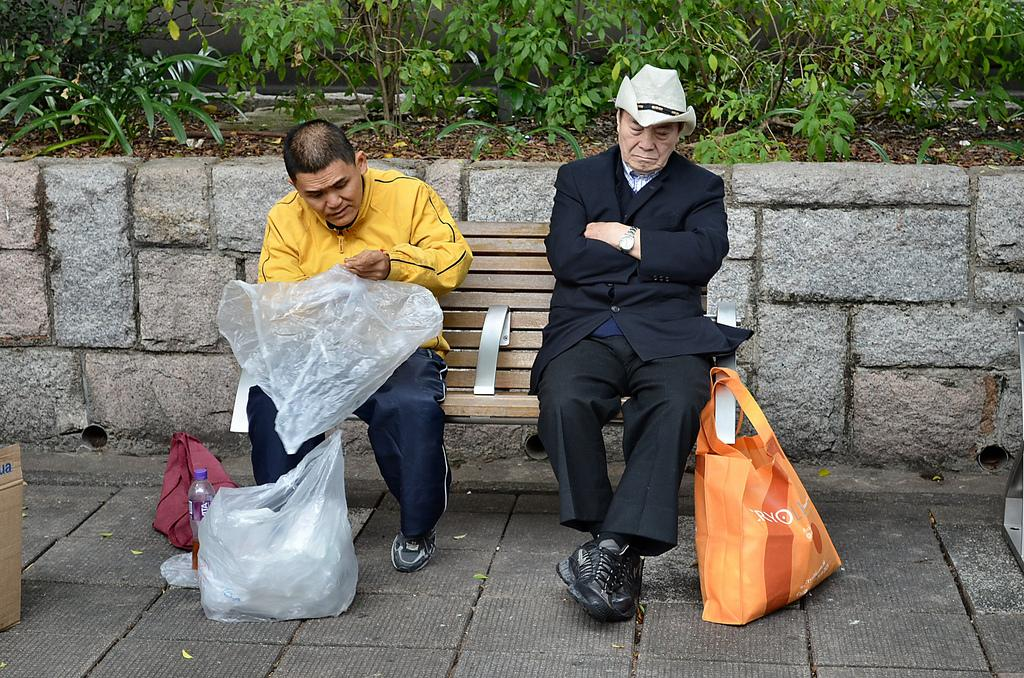Mention the primary object in the image and its most noticeable feature. A man in a suit is the main object, wearing a distinct white cowboy hat. What is the main person in the image wearing, and what are some nearby objects? The man wears a suit, white cowboy hat, and black shoes, with a water bottle and orange bag nearby. Describe the overall atmosphere or mood conveyed by the picture. The image conveys a peaceful and leisurely atmosphere, with a man relaxing on a park bench. Identify the central figure in the photo and summarize their appearance. The central figure is a man wearing a suit, white cowboy hat, and black shoes, sitting on a bench. What are the most prominent colors represented within the image? The most prominent colors in the image are orange, white, yellow, and black. Sum up the key components of the scene, using only a few words. Man, bench, stone wall, hat, bag, and water bottle. Briefly describe the key elements of the setting in the image. There's a man on a bench, with an orange bag and water bottle nearby, and a stone wall in the background. Comment on the position and relation of different objects in the image. A man is sitting on a bench with a water bottle and orange bag sitting on the ground nearby, while a stone wall serves as the backdrop. Describe the man's attire in the image and his immediate surroundings. The man is wearing a suit, cowboy hat, and black shoes, sitting on a bench near a water bottle and an orange bag. Mention the primary human subject and the characteristics of their clothes. The main subject is a man dressed in a suit, a white cowboy hat, and black sneakers. 